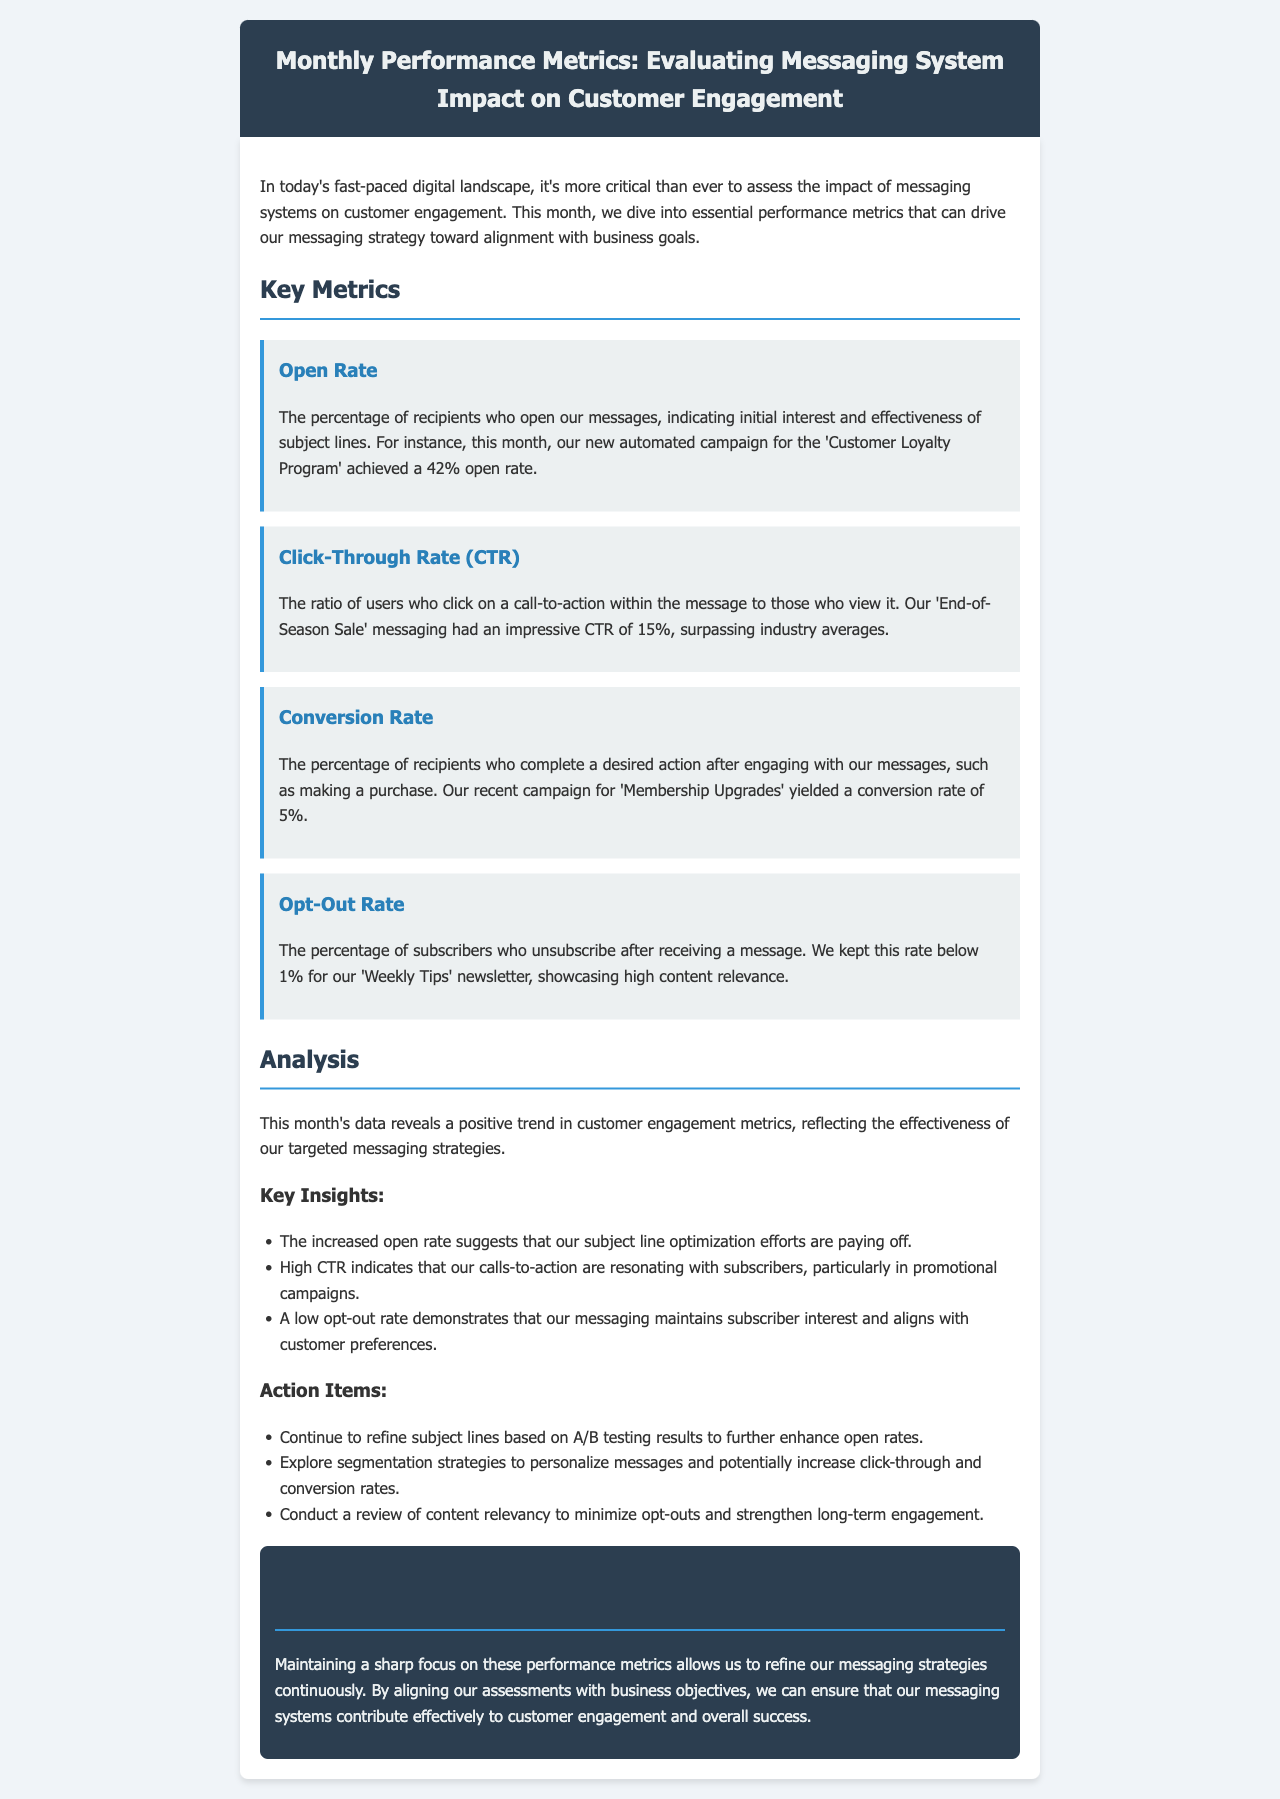What was the open rate for the 'Customer Loyalty Program'? The open rate for the 'Customer Loyalty Program' was 42%, as stated in the "Open Rate" section.
Answer: 42% What did the click-through rate for the 'End-of-Season Sale' messaging surpass? The click-through rate of 15% for the 'End-of-Season Sale' messaging surpassed industry averages, indicating a strong performance.
Answer: Industry averages What is the conversion rate for the 'Membership Upgrades' campaign? The conversion rate for the 'Membership Upgrades' campaign is mentioned as 5%.
Answer: 5% What is the opt-out rate for the 'Weekly Tips' newsletter? The document notes that the opt-out rate for the 'Weekly Tips' newsletter remained below 1%.
Answer: Below 1% What insight is associated with the increased open rate? The increased open rate indicates that subject line optimization efforts are paying off, as mentioned in the Key Insights section.
Answer: Subject line optimization What is one of the action items regarding click-through and conversion rates? The action item suggests exploring segmentation strategies to personalize messages and potentially increase click-through and conversion rates.
Answer: Segmenting strategies What color scheme is used for the header? The header's background color is dark blue (#2c3e50) with light text (#ecf0f1), creating a clear contrast.
Answer: Dark blue and light text What does the newsletter state about the overall trend in customer engagement metrics? The document reveals a positive trend in customer engagement metrics, reflecting the effectiveness of targeted messaging strategies.
Answer: Positive trend What should be conducted to minimize opt-outs? The document suggests conducting a review of content relevancy to help minimize opt-outs and strengthen engagement.
Answer: Review of content relevancy 